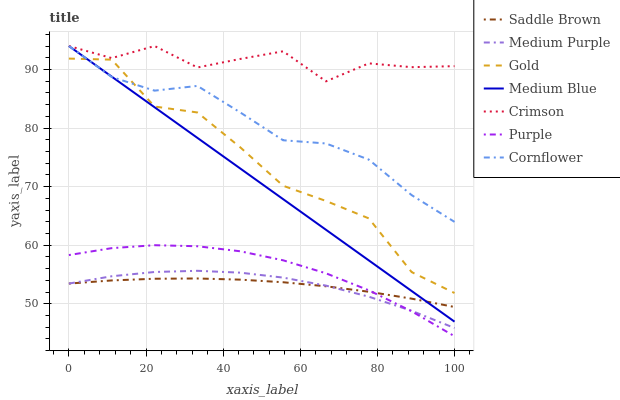Does Saddle Brown have the minimum area under the curve?
Answer yes or no. Yes. Does Crimson have the maximum area under the curve?
Answer yes or no. Yes. Does Gold have the minimum area under the curve?
Answer yes or no. No. Does Gold have the maximum area under the curve?
Answer yes or no. No. Is Medium Blue the smoothest?
Answer yes or no. Yes. Is Gold the roughest?
Answer yes or no. Yes. Is Purple the smoothest?
Answer yes or no. No. Is Purple the roughest?
Answer yes or no. No. Does Gold have the lowest value?
Answer yes or no. No. Does Crimson have the highest value?
Answer yes or no. Yes. Does Gold have the highest value?
Answer yes or no. No. Is Medium Purple less than Gold?
Answer yes or no. Yes. Is Cornflower greater than Saddle Brown?
Answer yes or no. Yes. Does Medium Purple intersect Gold?
Answer yes or no. No. 